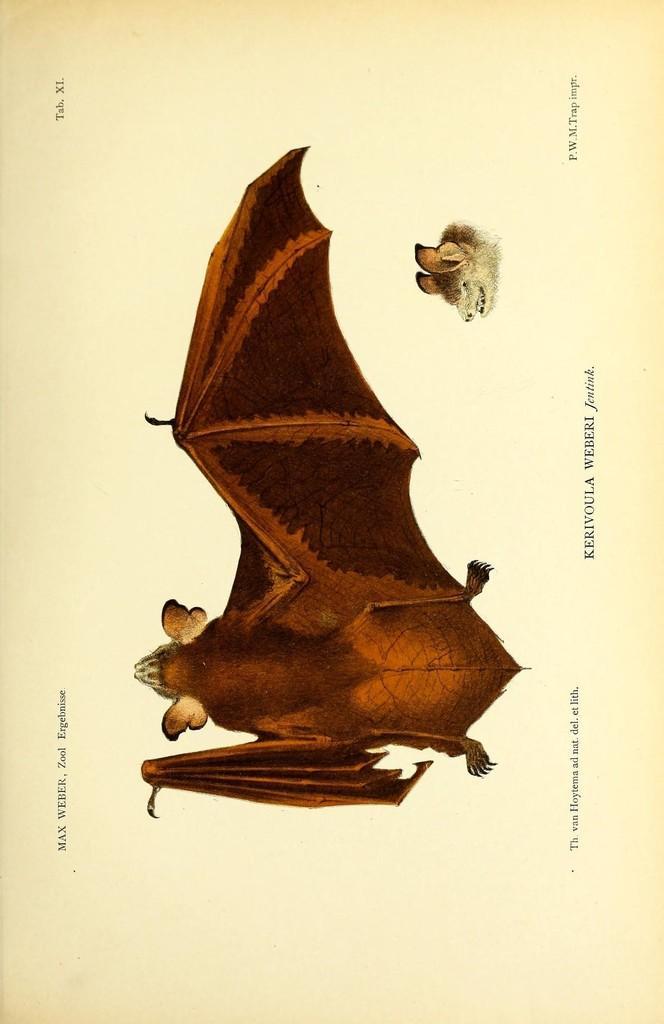In one or two sentences, can you explain what this image depicts? In this image I can see a drawing of an animal and there is a face below it. Some matter is written. 